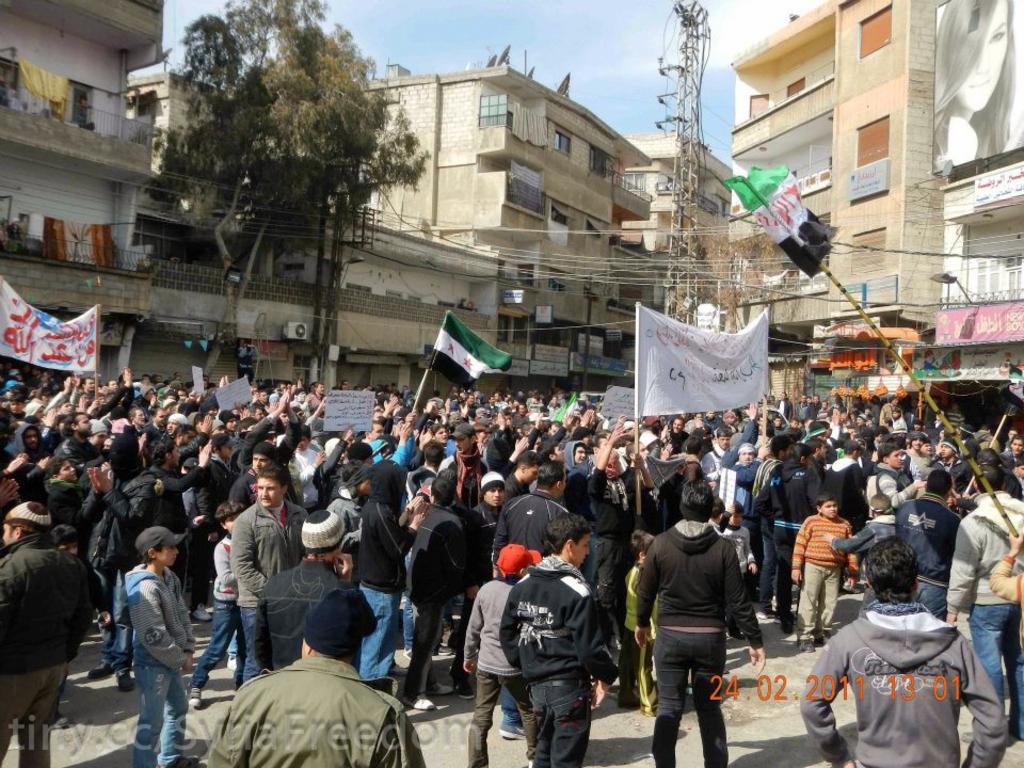Can you describe this image briefly? In this picture we can see some people standing in the front, some of them are holding flags, in the background we can see buildings, on the left side there is a tree, we can see a tower in the middle, in the background there are some boards and wires, there is the sky at the top of the picture, at the left bottom there is some text, there is a hoarding at the right top of the picture. 